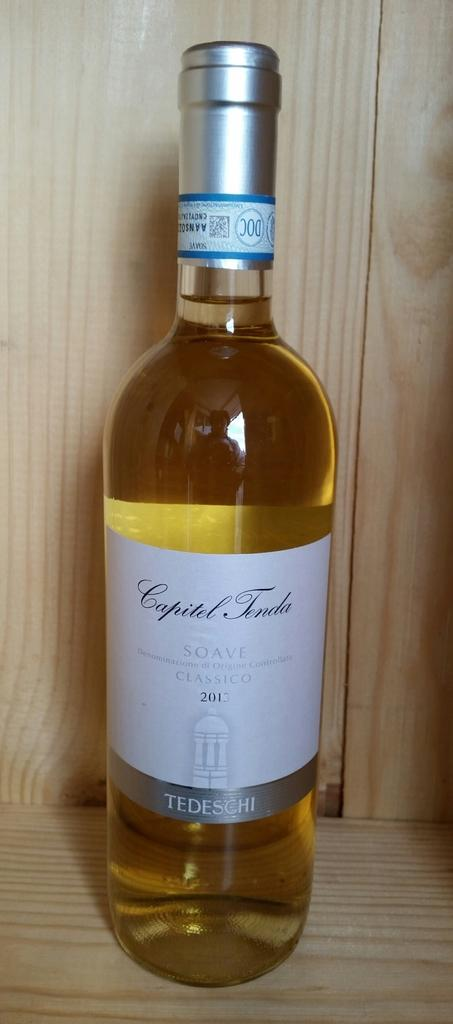<image>
Give a short and clear explanation of the subsequent image. A full bottle of white wine from  2013 